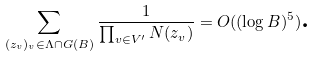Convert formula to latex. <formula><loc_0><loc_0><loc_500><loc_500>\sum _ { ( { z } _ { v } ) _ { v } \in \Lambda \cap G ( B ) } \frac { 1 } { \prod _ { v \in V ^ { \prime } } N ( { z } _ { v } ) } = O ( ( \log B ) ^ { 5 } ) \text  .</formula> 